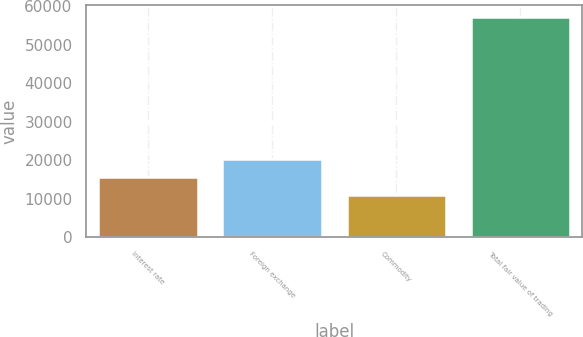Convert chart to OTSL. <chart><loc_0><loc_0><loc_500><loc_500><bar_chart><fcel>Interest rate<fcel>Foreign exchange<fcel>Commodity<fcel>Total fair value of trading<nl><fcel>15707<fcel>20330<fcel>11084<fcel>57314<nl></chart> 